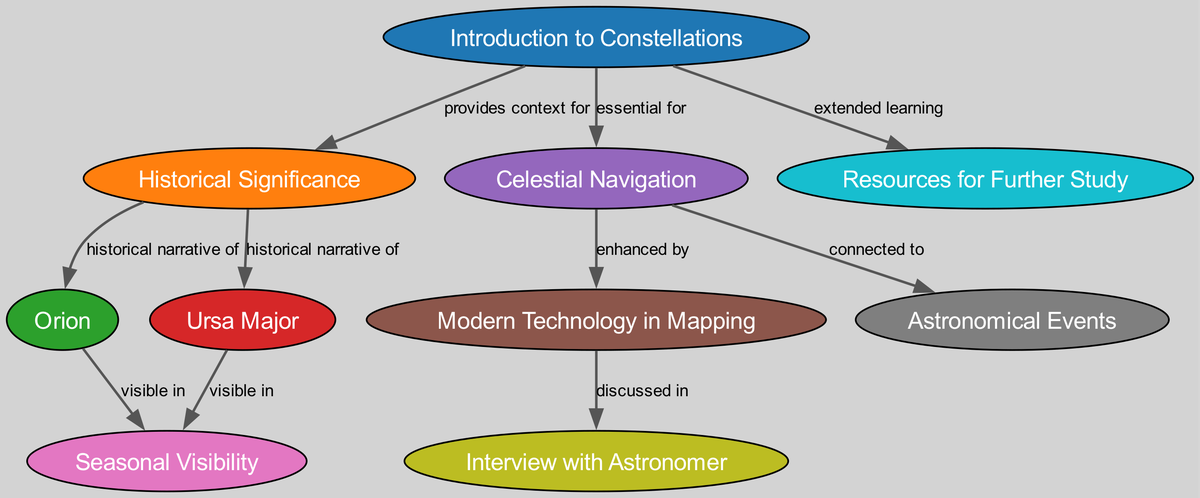What is the total number of nodes in the diagram? The total number of nodes can be found by counting the items listed in the "nodes" section of the data. There are 10 nodes, each representing a specific topic related to constellation mapping.
Answer: 10 Which node discusses the historical narrative of Orion? To find the answer, we look at the edges and see that there is a relationship connecting the "Historical Significance" node (ID 2) to the "Orion" node (ID 3), indicating that Orion is discussed in relation to historical narratives.
Answer: Orion What type of relationship exists between "Celestial Navigation" and "Modern Technology in Mapping"? By examining the edges in the diagram, we find that there is a direct edge from "Celestial Navigation" (ID 5) to "Modern Technology in Mapping" (ID 6) which indicates that technology enhances navigation, signaling a relationship of enhancement.
Answer: enhanced by Which two constellations are visible in the same season? Both the "Orion" node (ID 3) and "Ursa Major" node (ID 4) are connected to the "Seasonal Visibility" node (ID 7), indicating that they can be viewed during certain seasons. Since they are mentioned together in this context, the answer includes them both.
Answer: Orion, Ursa Major What is the connection between "Celestial Navigation" and "Astronomical Events"? The relationship between these two nodes is specified in the edges section of the data, showing that celestial navigation is connected to astronomical events, indicating how constellations play a role in these occurrences.
Answer: connected to 